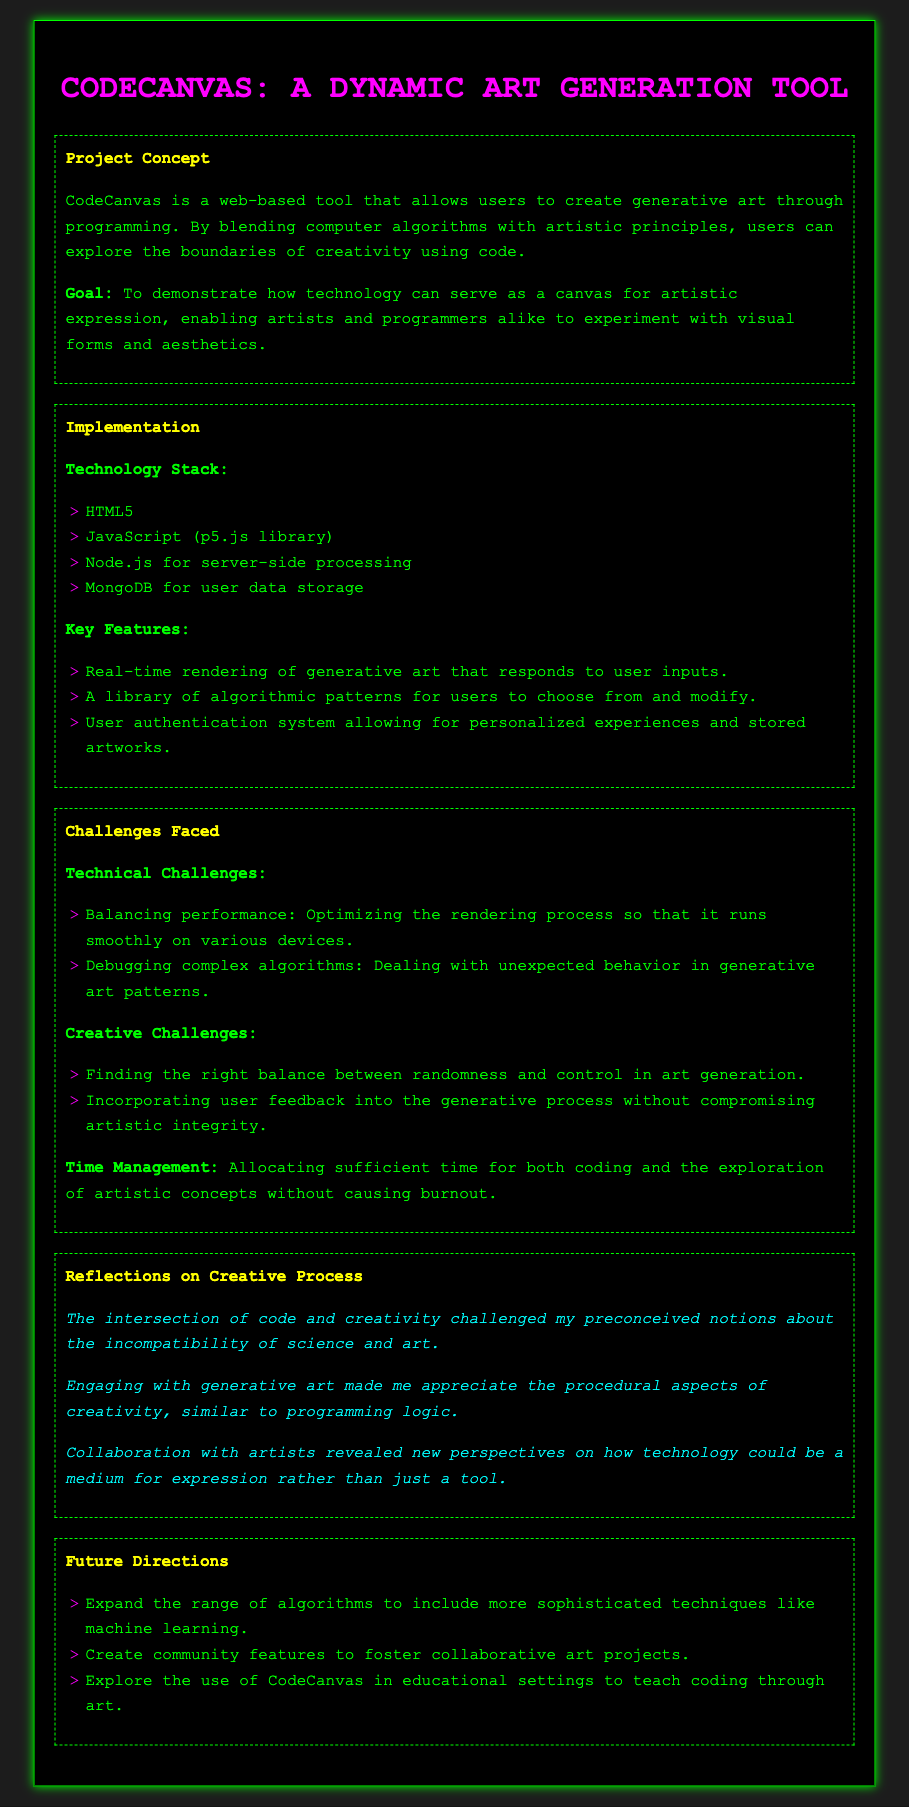What is the title of the project? The title of the project is mentioned in the header of the document as "CodeCanvas: A Dynamic Art Generation Tool."
Answer: CodeCanvas: A Dynamic Art Generation Tool What technology stack is used? The document lists the technology stack under the implementation section, specifying the technologies utilized.
Answer: HTML5, JavaScript, Node.js, MongoDB Which library is used for programming? The document specifically mentions the use of a library in the technology stack for programming generative art.
Answer: p5.js What is a key feature of CodeCanvas? The document highlights several features; one is mentioned as a key benefit of the tool regarding user interaction.
Answer: Real-time rendering What was a technical challenge faced during the project? The document describes several challenges under the challenges section, including one related to performance.
Answer: Balancing performance What reflection highlights the interaction of science and creativity? One of the reflections in the document addresses the relationship between code and creativity, capturing the author's insight.
Answer: challenged my preconceived notions about the incompatibility of science and art How does the project plan to engage the community in the future? The document outlines future directions, including plans to create communal aspects for collaborative engagements.
Answer: community features Which user support feature is included in the implementation? The document lists features that support user experience, emphasizing personalization and user-created content.
Answer: User authentication system 